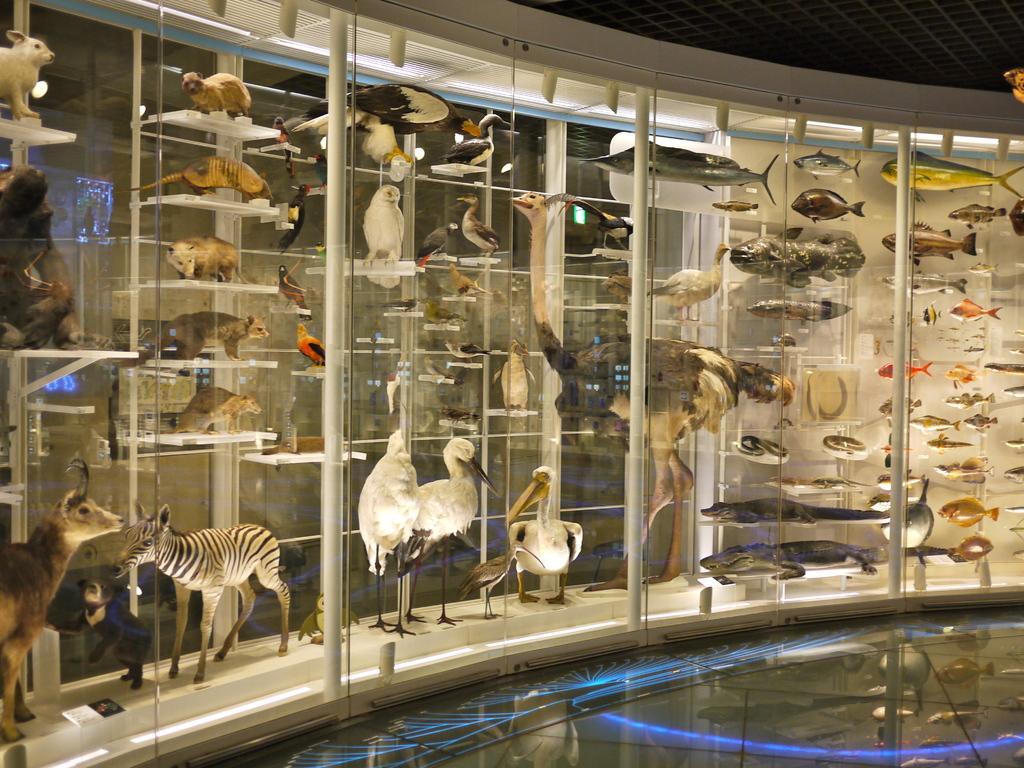Could you give a brief overview of what you see in this image? In the picture we can see a glass cupboard inside it, we can see some animals, birds and different kinds of fishes and reptiles and near to it we can see a floor with a blue color lighting on it. 